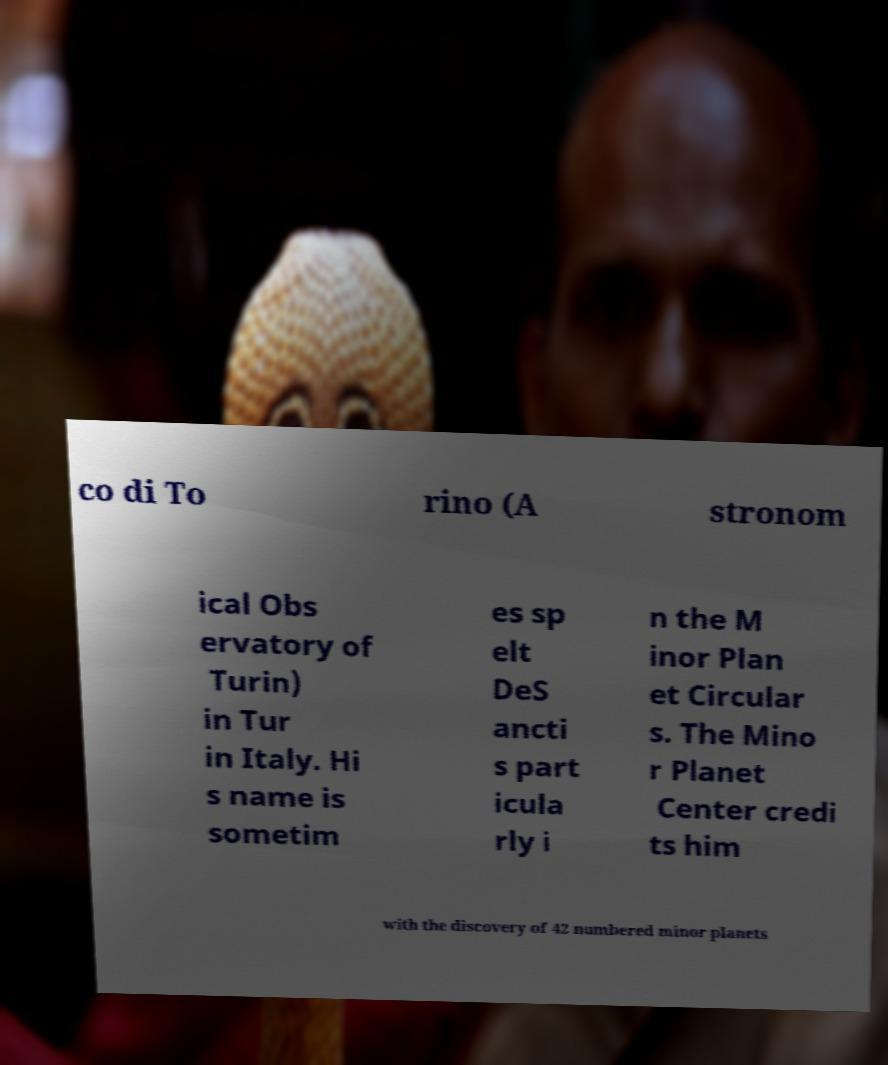Can you accurately transcribe the text from the provided image for me? co di To rino (A stronom ical Obs ervatory of Turin) in Tur in Italy. Hi s name is sometim es sp elt DeS ancti s part icula rly i n the M inor Plan et Circular s. The Mino r Planet Center credi ts him with the discovery of 42 numbered minor planets 